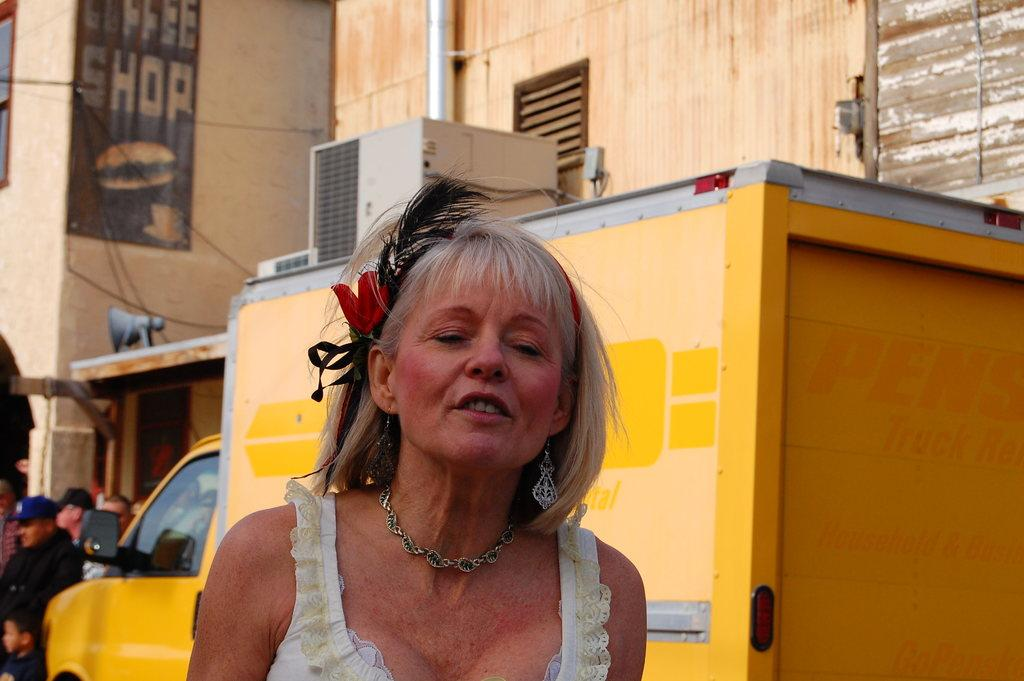<image>
Share a concise interpretation of the image provided. A woman in a lace-trimmed top stands near a yellow truck, in front of a coffee shop sign on the side of a building. 